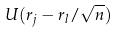Convert formula to latex. <formula><loc_0><loc_0><loc_500><loc_500>U ( r _ { j } - r _ { l } / \sqrt { n } )</formula> 